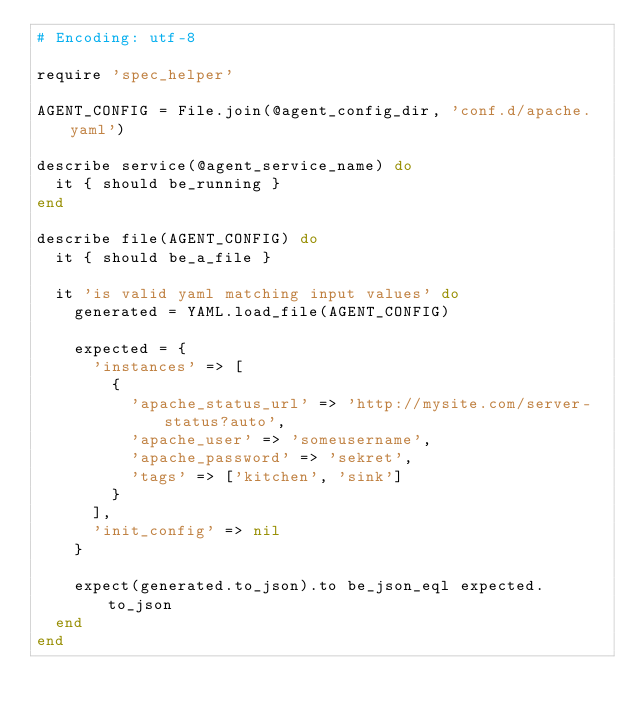Convert code to text. <code><loc_0><loc_0><loc_500><loc_500><_Ruby_># Encoding: utf-8

require 'spec_helper'

AGENT_CONFIG = File.join(@agent_config_dir, 'conf.d/apache.yaml')

describe service(@agent_service_name) do
  it { should be_running }
end

describe file(AGENT_CONFIG) do
  it { should be_a_file }

  it 'is valid yaml matching input values' do
    generated = YAML.load_file(AGENT_CONFIG)

    expected = {
      'instances' => [
        {
          'apache_status_url' => 'http://mysite.com/server-status?auto',
          'apache_user' => 'someusername',
          'apache_password' => 'sekret',
          'tags' => ['kitchen', 'sink']
        }
      ],
      'init_config' => nil
    }

    expect(generated.to_json).to be_json_eql expected.to_json
  end
end
</code> 